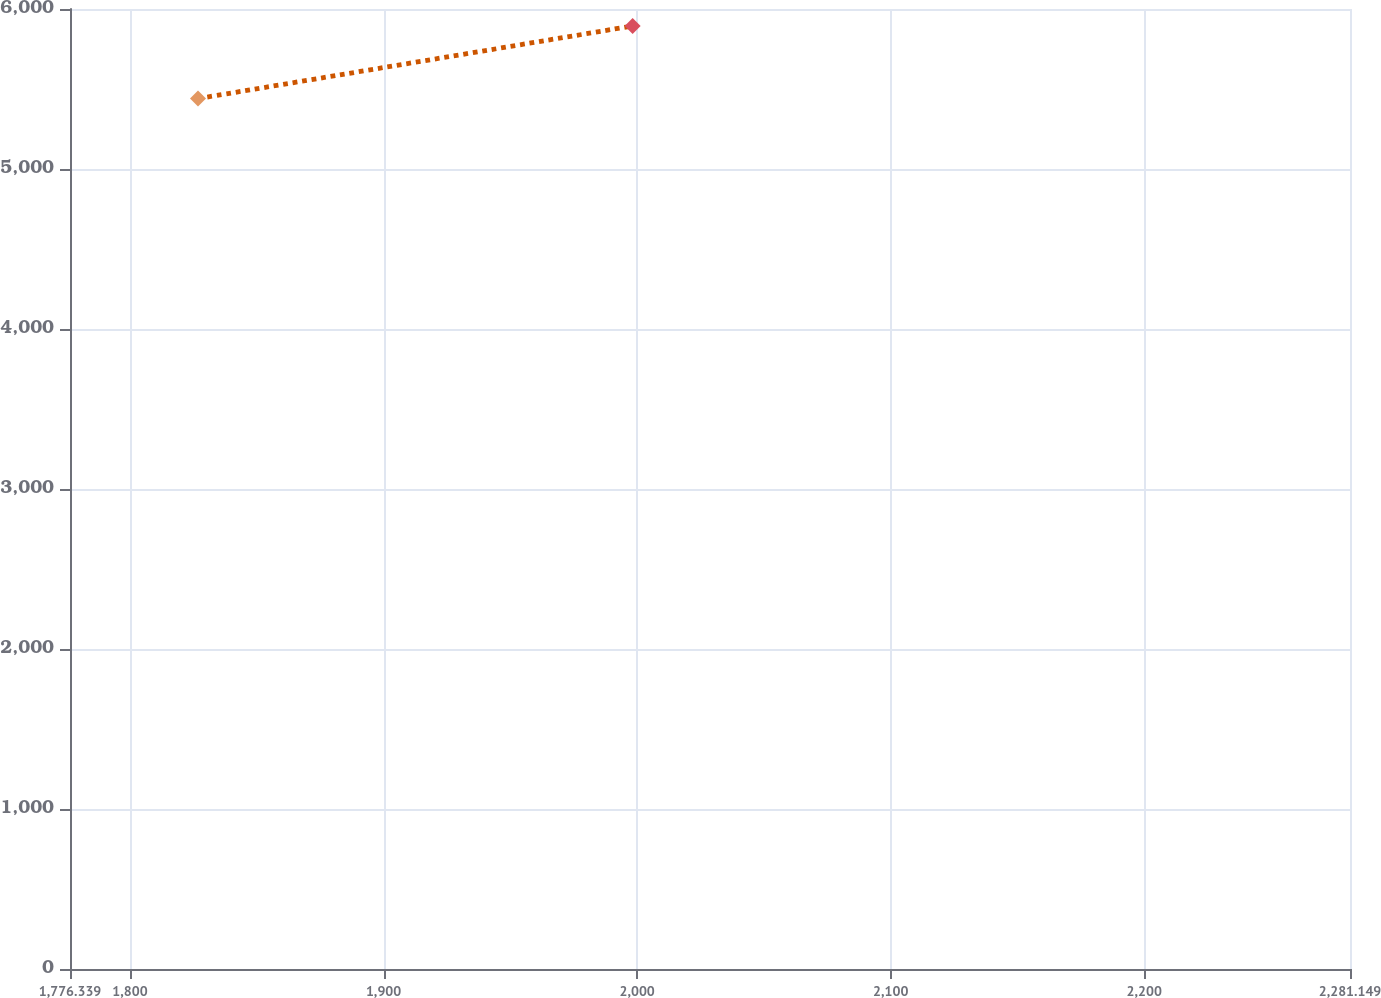Convert chart. <chart><loc_0><loc_0><loc_500><loc_500><line_chart><ecel><fcel>Unnamed: 1<nl><fcel>1826.82<fcel>5440.18<nl><fcel>1998.22<fcel>5893.93<nl><fcel>2282.93<fcel>4394.99<nl><fcel>2331.63<fcel>5590.07<nl></chart> 